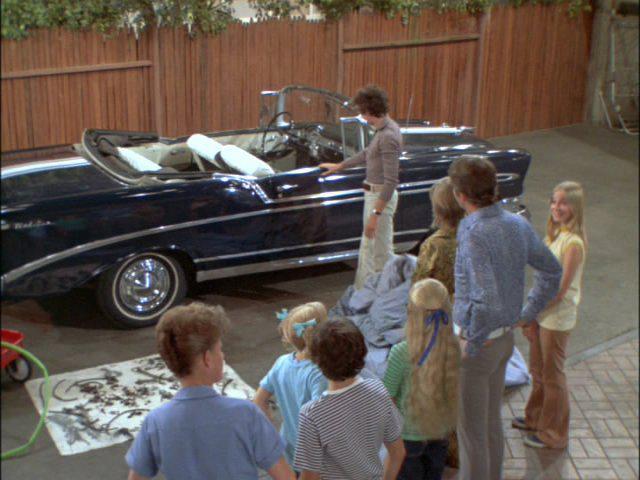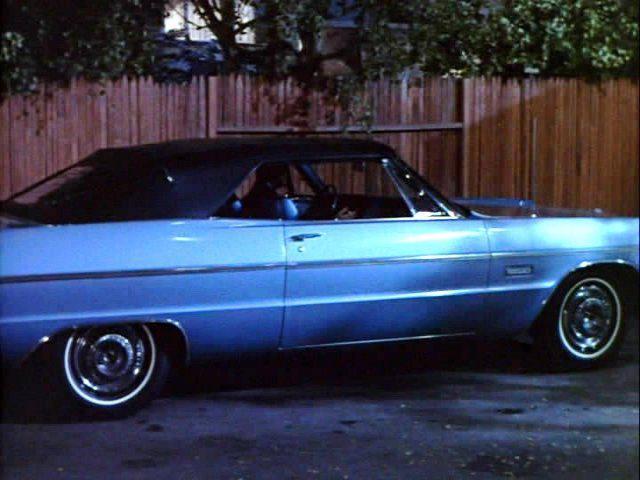The first image is the image on the left, the second image is the image on the right. Evaluate the accuracy of this statement regarding the images: "An image shows a young man behind the wheel of a powder blue convertible with top down.". Is it true? Answer yes or no. No. The first image is the image on the left, the second image is the image on the right. Analyze the images presented: Is the assertion "Neither of the cars has a hood or roof on it." valid? Answer yes or no. No. 